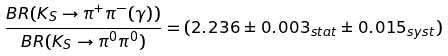Convert formula to latex. <formula><loc_0><loc_0><loc_500><loc_500>\frac { B R ( K _ { S } \to \pi ^ { + } \pi ^ { - } ( \gamma ) ) } { B R ( K _ { S } \to \pi ^ { 0 } \pi ^ { 0 } ) } = ( 2 . 2 3 6 \pm 0 . 0 0 3 _ { s t a t } \pm 0 . 0 1 5 _ { s y s t } )</formula> 